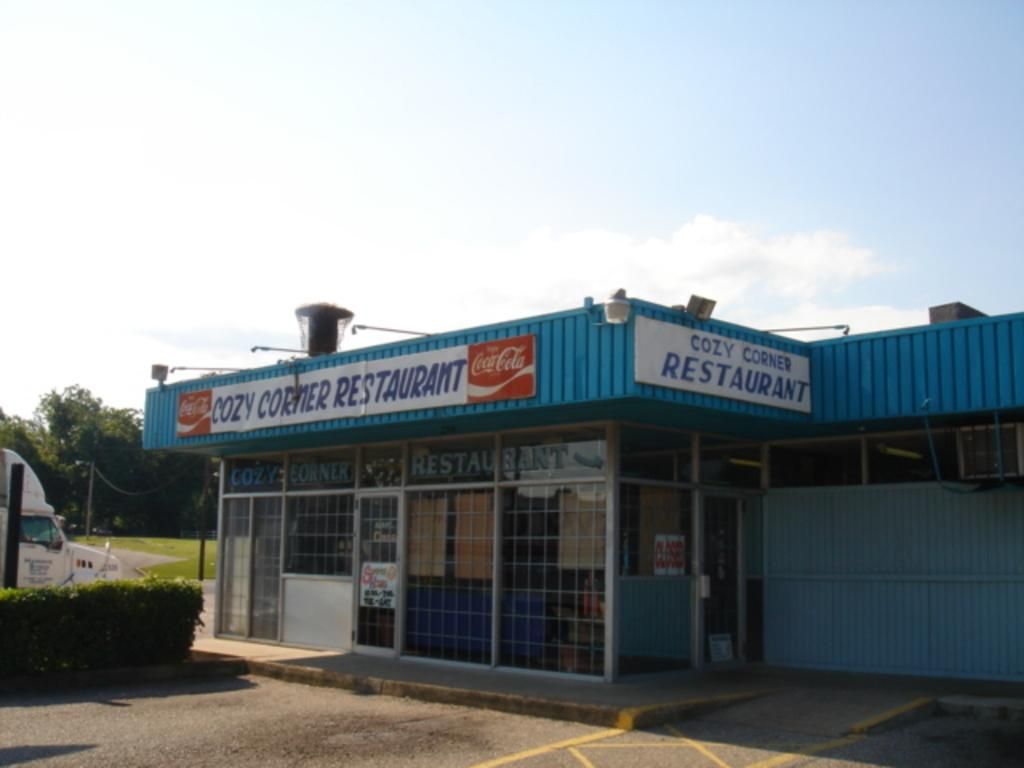What type of establishment is located in the center of the image? There is a store in the center of the image. What can be seen on the left side of the image? There is a vehicle on the left side of the image. What is at the bottom of the image? There is a hedge at the bottom of the image. What is visible in the background of the image? There are trees and the sky in the background of the image. What type of stone is used to create the cactus in the image? There is no cactus present in the image, so it is not possible to determine the type of stone used. What song is being played in the background of the image? There is no indication of any music or song in the image, so it cannot be determined from the image. 